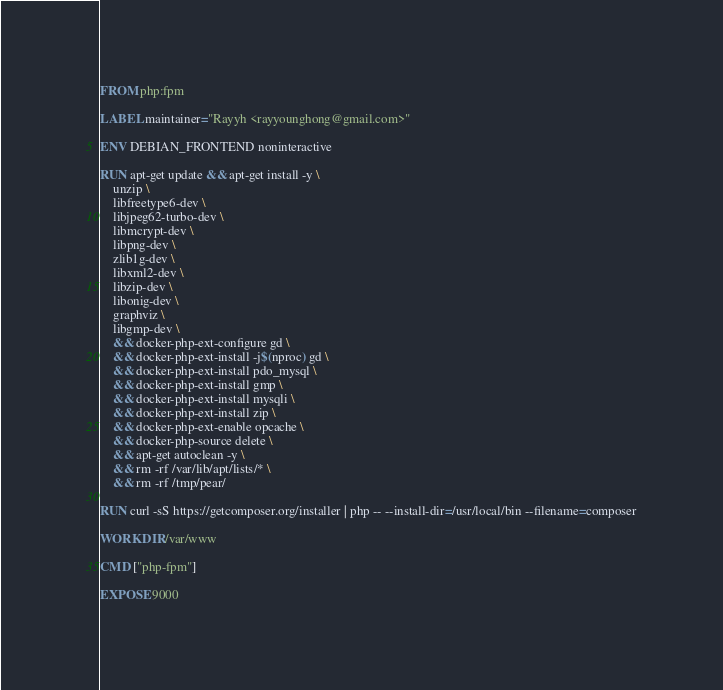Convert code to text. <code><loc_0><loc_0><loc_500><loc_500><_Dockerfile_>FROM php:fpm

LABEL maintainer="Rayyh <rayyounghong@gmail.com>"

ENV DEBIAN_FRONTEND noninteractive

RUN apt-get update && apt-get install -y \
    unzip \
    libfreetype6-dev \
    libjpeg62-turbo-dev \
    libmcrypt-dev \
    libpng-dev \
    zlib1g-dev \
    libxml2-dev \
    libzip-dev \
    libonig-dev \
    graphviz \
    libgmp-dev \
    && docker-php-ext-configure gd \
    && docker-php-ext-install -j$(nproc) gd \
    && docker-php-ext-install pdo_mysql \
    && docker-php-ext-install gmp \
    && docker-php-ext-install mysqli \
    && docker-php-ext-install zip \
    && docker-php-ext-enable opcache \
    && docker-php-source delete \
    && apt-get autoclean -y \
    && rm -rf /var/lib/apt/lists/* \
    && rm -rf /tmp/pear/

RUN curl -sS https://getcomposer.org/installer | php -- --install-dir=/usr/local/bin --filename=composer

WORKDIR /var/www

CMD ["php-fpm"]

EXPOSE 9000
</code> 